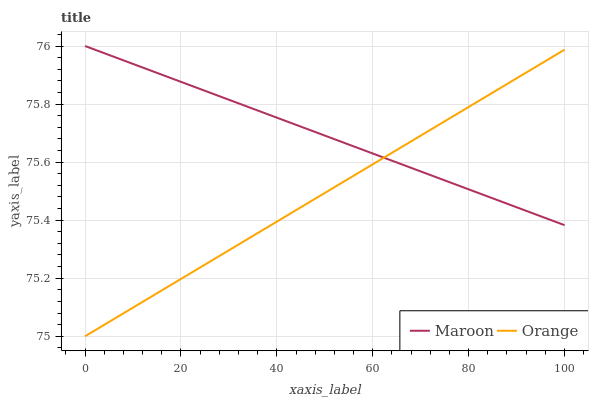Does Orange have the minimum area under the curve?
Answer yes or no. Yes. Does Maroon have the maximum area under the curve?
Answer yes or no. Yes. Does Maroon have the minimum area under the curve?
Answer yes or no. No. Is Maroon the smoothest?
Answer yes or no. Yes. Is Orange the roughest?
Answer yes or no. Yes. Is Maroon the roughest?
Answer yes or no. No. Does Orange have the lowest value?
Answer yes or no. Yes. Does Maroon have the lowest value?
Answer yes or no. No. Does Maroon have the highest value?
Answer yes or no. Yes. Does Maroon intersect Orange?
Answer yes or no. Yes. Is Maroon less than Orange?
Answer yes or no. No. Is Maroon greater than Orange?
Answer yes or no. No. 